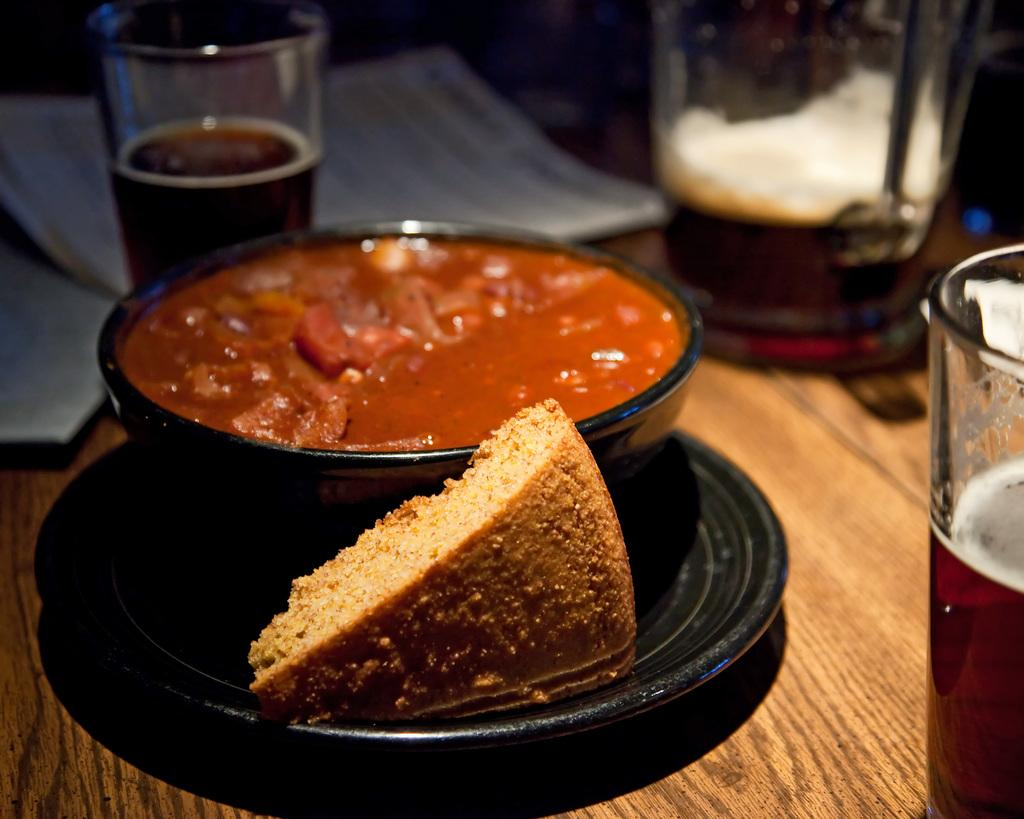What type of table is in the image? There is a wooden table in the image. What is on the table? There is a black plate containing bread, a bowl of curry, and glasses of drink on the table. Are there any additional items on the table? Yes, papers are present at the back of the table. What type of fear can be seen on the faces of the people in the image? There are no people present in the image, so it is not possible to determine their emotions or fears. 